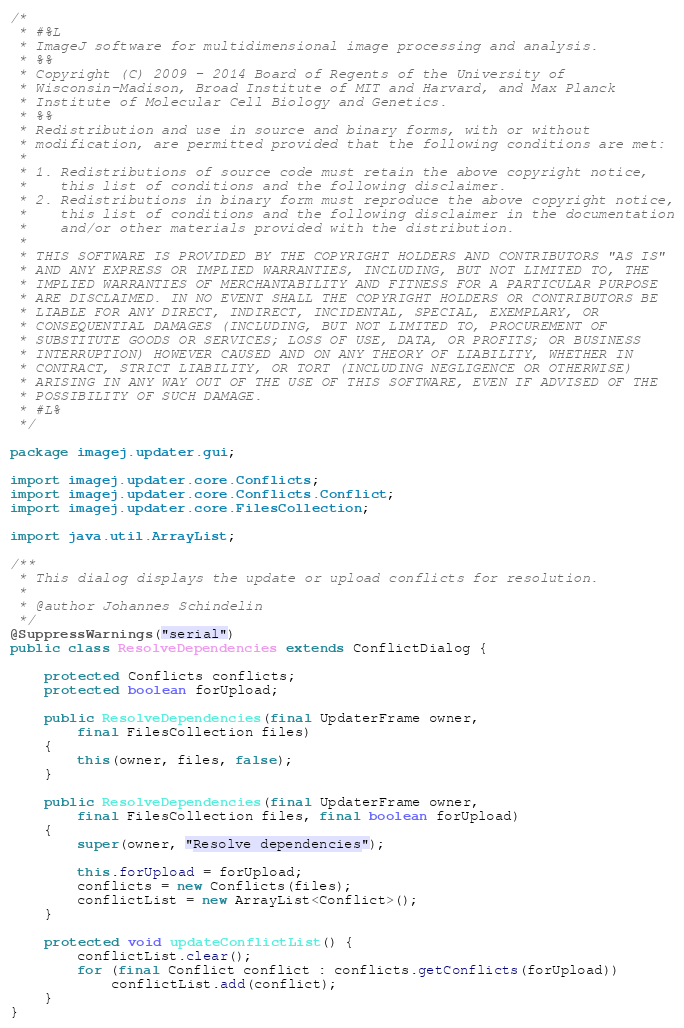Convert code to text. <code><loc_0><loc_0><loc_500><loc_500><_Java_>/*
 * #%L
 * ImageJ software for multidimensional image processing and analysis.
 * %%
 * Copyright (C) 2009 - 2014 Board of Regents of the University of
 * Wisconsin-Madison, Broad Institute of MIT and Harvard, and Max Planck
 * Institute of Molecular Cell Biology and Genetics.
 * %%
 * Redistribution and use in source and binary forms, with or without
 * modification, are permitted provided that the following conditions are met:
 * 
 * 1. Redistributions of source code must retain the above copyright notice,
 *    this list of conditions and the following disclaimer.
 * 2. Redistributions in binary form must reproduce the above copyright notice,
 *    this list of conditions and the following disclaimer in the documentation
 *    and/or other materials provided with the distribution.
 * 
 * THIS SOFTWARE IS PROVIDED BY THE COPYRIGHT HOLDERS AND CONTRIBUTORS "AS IS"
 * AND ANY EXPRESS OR IMPLIED WARRANTIES, INCLUDING, BUT NOT LIMITED TO, THE
 * IMPLIED WARRANTIES OF MERCHANTABILITY AND FITNESS FOR A PARTICULAR PURPOSE
 * ARE DISCLAIMED. IN NO EVENT SHALL THE COPYRIGHT HOLDERS OR CONTRIBUTORS BE
 * LIABLE FOR ANY DIRECT, INDIRECT, INCIDENTAL, SPECIAL, EXEMPLARY, OR
 * CONSEQUENTIAL DAMAGES (INCLUDING, BUT NOT LIMITED TO, PROCUREMENT OF
 * SUBSTITUTE GOODS OR SERVICES; LOSS OF USE, DATA, OR PROFITS; OR BUSINESS
 * INTERRUPTION) HOWEVER CAUSED AND ON ANY THEORY OF LIABILITY, WHETHER IN
 * CONTRACT, STRICT LIABILITY, OR TORT (INCLUDING NEGLIGENCE OR OTHERWISE)
 * ARISING IN ANY WAY OUT OF THE USE OF THIS SOFTWARE, EVEN IF ADVISED OF THE
 * POSSIBILITY OF SUCH DAMAGE.
 * #L%
 */

package imagej.updater.gui;

import imagej.updater.core.Conflicts;
import imagej.updater.core.Conflicts.Conflict;
import imagej.updater.core.FilesCollection;

import java.util.ArrayList;

/**
 * This dialog displays the update or upload conflicts for resolution.
 * 
 * @author Johannes Schindelin
 */
@SuppressWarnings("serial")
public class ResolveDependencies extends ConflictDialog {

	protected Conflicts conflicts;
	protected boolean forUpload;

	public ResolveDependencies(final UpdaterFrame owner,
		final FilesCollection files)
	{
		this(owner, files, false);
	}

	public ResolveDependencies(final UpdaterFrame owner,
		final FilesCollection files, final boolean forUpload)
	{
		super(owner, "Resolve dependencies");

		this.forUpload = forUpload;
		conflicts = new Conflicts(files);
		conflictList = new ArrayList<Conflict>();
	}

	protected void updateConflictList() {
		conflictList.clear();
		for (final Conflict conflict : conflicts.getConflicts(forUpload))
			conflictList.add(conflict);
	}
}
</code> 